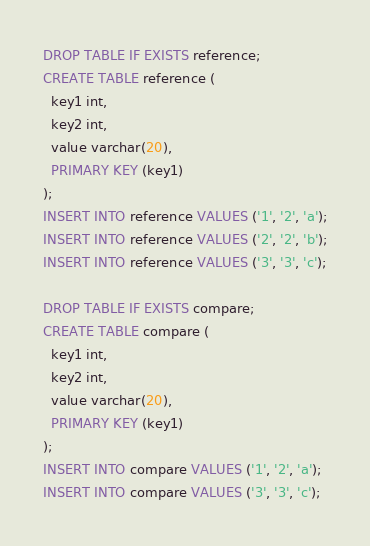<code> <loc_0><loc_0><loc_500><loc_500><_SQL_>DROP TABLE IF EXISTS reference;
CREATE TABLE reference (
  key1 int,
  key2 int,
  value varchar(20),
  PRIMARY KEY (key1)
);
INSERT INTO reference VALUES ('1', '2', 'a');
INSERT INTO reference VALUES ('2', '2', 'b');
INSERT INTO reference VALUES ('3', '3', 'c');

DROP TABLE IF EXISTS compare;
CREATE TABLE compare (
  key1 int,
  key2 int,
  value varchar(20),
  PRIMARY KEY (key1)
);
INSERT INTO compare VALUES ('1', '2', 'a');
INSERT INTO compare VALUES ('3', '3', 'c');</code> 